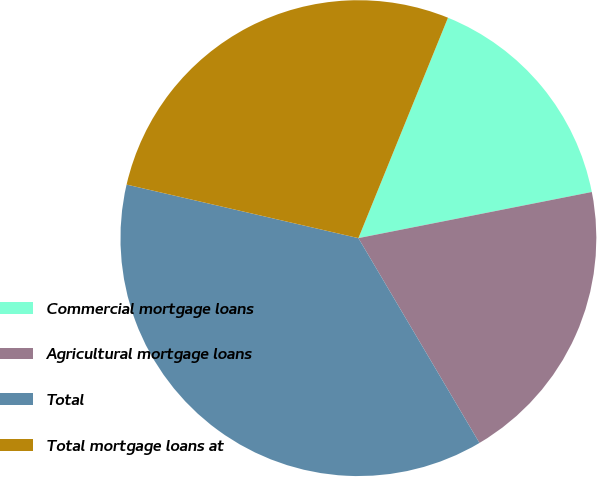Convert chart to OTSL. <chart><loc_0><loc_0><loc_500><loc_500><pie_chart><fcel>Commercial mortgage loans<fcel>Agricultural mortgage loans<fcel>Total<fcel>Total mortgage loans at<nl><fcel>15.75%<fcel>19.61%<fcel>37.11%<fcel>27.53%<nl></chart> 